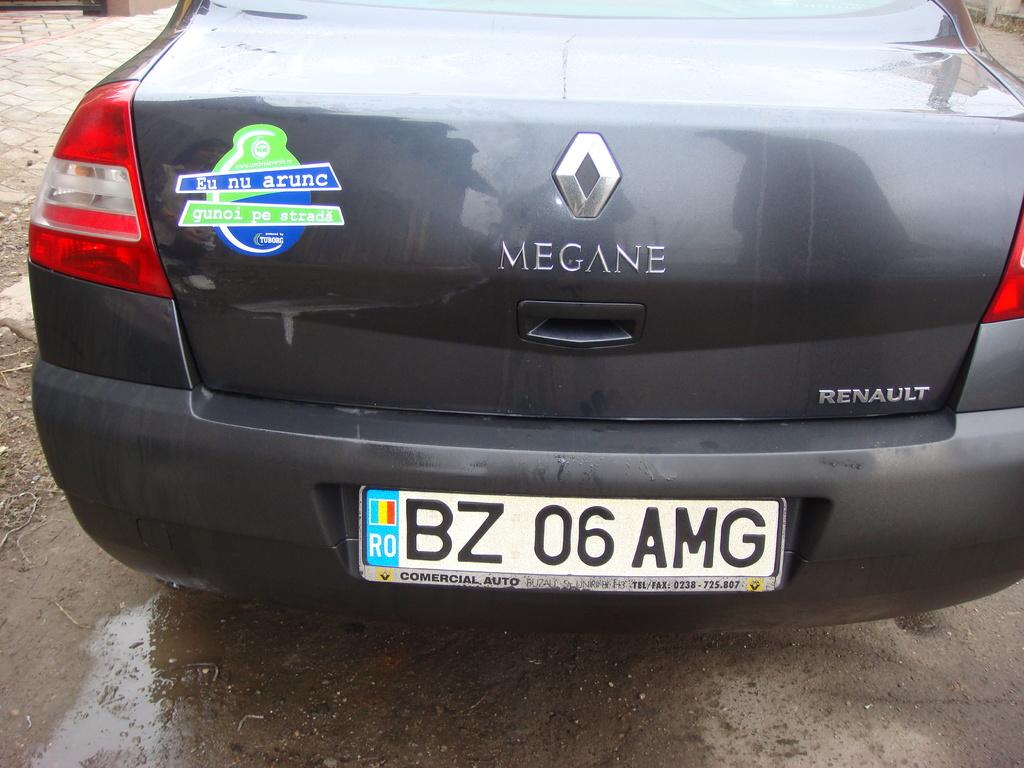<image>
Write a terse but informative summary of the picture. A dark gray Magne Renault Automobile with a European license plate. 